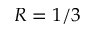<formula> <loc_0><loc_0><loc_500><loc_500>R = 1 / 3</formula> 